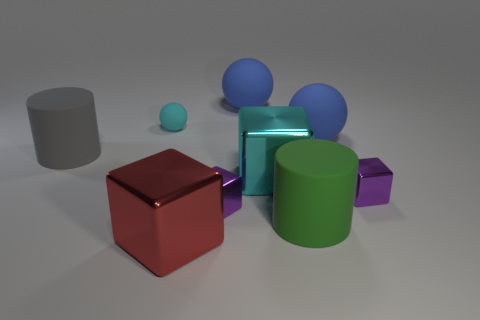Subtract all large cyan metallic blocks. How many blocks are left? 3 Subtract all cyan spheres. How many spheres are left? 2 Subtract all cyan cylinders. How many green balls are left? 0 Subtract all large gray shiny blocks. Subtract all big things. How many objects are left? 3 Add 4 small cyan rubber spheres. How many small cyan rubber spheres are left? 5 Add 8 gray rubber cylinders. How many gray rubber cylinders exist? 9 Subtract 0 yellow balls. How many objects are left? 9 Subtract all blocks. How many objects are left? 5 Subtract all yellow cylinders. Subtract all yellow blocks. How many cylinders are left? 2 